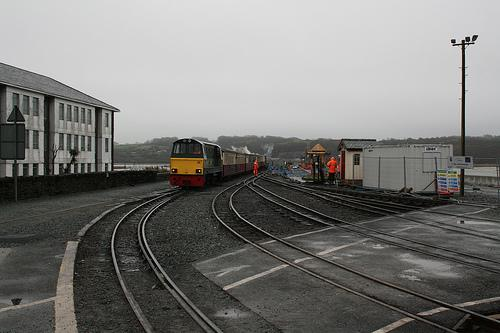Comment on the landscape that is depicted in the image. The picture portrays a trainyard with several sets of tracks, hills, and trees in the background, emphasizing an expansive and slightly hilly landscape. Highlight the color and characteristics of the sky in the photo. The image displays a gray, overcast sky encompassing a large portion of the scene, creating a somewhat gloomy atmosphere. Describe the presence of people within the image. There are individuals wearing orange jackets, possibly train workers or construction personnel, standing near the train tracks while going about their duties. Mention the buildings present in the background of the image. There is a three-story white building with multiple windows and another building at the edge of the trainyard, both situated near the train tracks. Mention any important details about the buildings in the image. The buildings in the image include a three-story white building with multiple windows, a small shed near the tracks, and a multi-story building in the background. Talk about the various elements in the foreground of the picture. In the foreground, there are train tracks, a fence with a sign, and people wearing orange jackets, creating an industrial and busy atmosphere. Provide a brief overview of the scene depicted in the image. A train on multiple tracks is surrounded by a fence, buildings, and hills, with people wearing orange jackets and street lights on a pole under a gray overcast sky. Describe the natural elements present within the picture. Natural elements in the image include the gray sky, a collection of trees in the background, and the hilly terrain that makes up part of the landscape. Describe the various signs and lighting present in the image. There are tall poles with floodlights on top, a triangular street sign, and signs attached to a chain-link fence providing information and possible warnings. Describe the train visible within the photo. The train in the image has a yellow and red front, headlights, and it is situated on one of the multiple tracks within the trainyard. Is there a round street sign near the tracks? No, it's not mentioned in the image. 